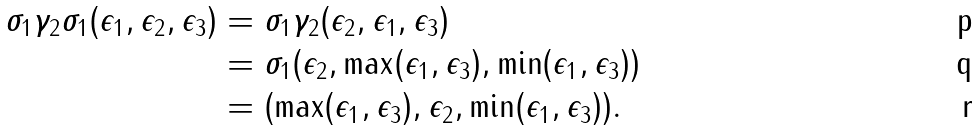<formula> <loc_0><loc_0><loc_500><loc_500>\sigma _ { 1 } \gamma _ { 2 } \sigma _ { 1 } ( \epsilon _ { 1 } , \epsilon _ { 2 } , \epsilon _ { 3 } ) & = \sigma _ { 1 } \gamma _ { 2 } ( \epsilon _ { 2 } , \epsilon _ { 1 } , \epsilon _ { 3 } ) & \\ & = \sigma _ { 1 } ( \epsilon _ { 2 } , \max ( \epsilon _ { 1 } , \epsilon _ { 3 } ) , \min ( \epsilon _ { 1 } , \epsilon _ { 3 } ) ) & \\ & = ( \max ( \epsilon _ { 1 } , \epsilon _ { 3 } ) , \epsilon _ { 2 } , \min ( \epsilon _ { 1 } , \epsilon _ { 3 } ) ) .</formula> 